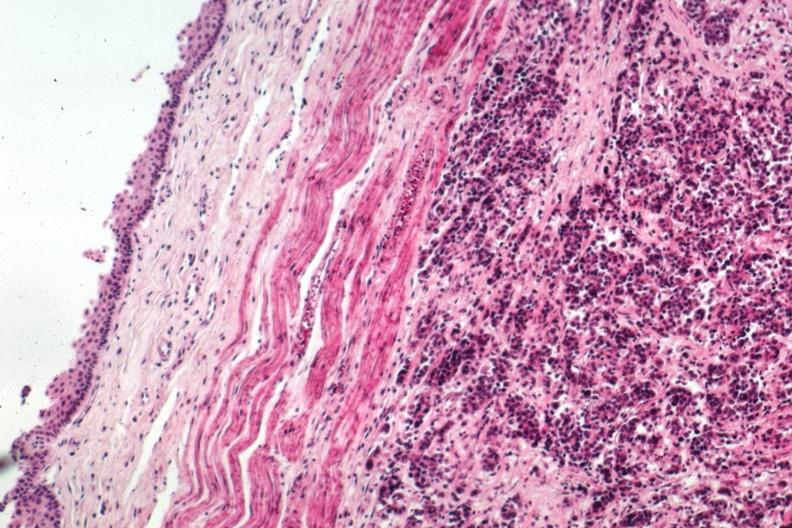what is present?
Answer the question using a single word or phrase. Esophagus 